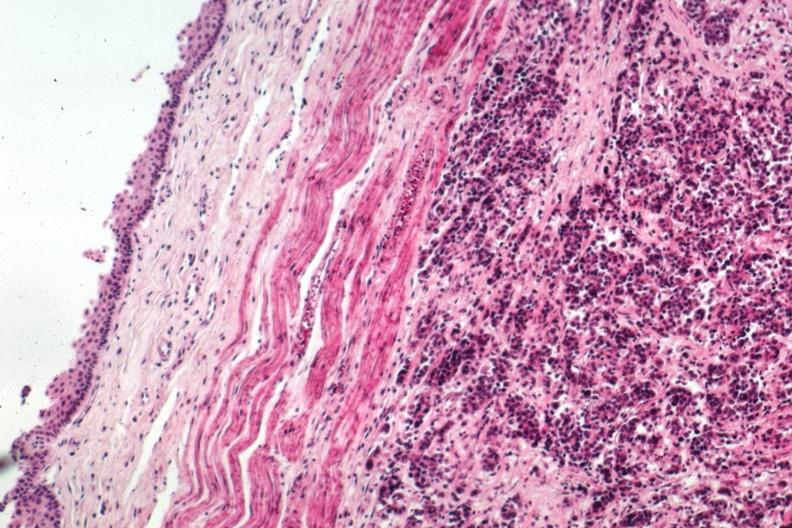what is present?
Answer the question using a single word or phrase. Esophagus 